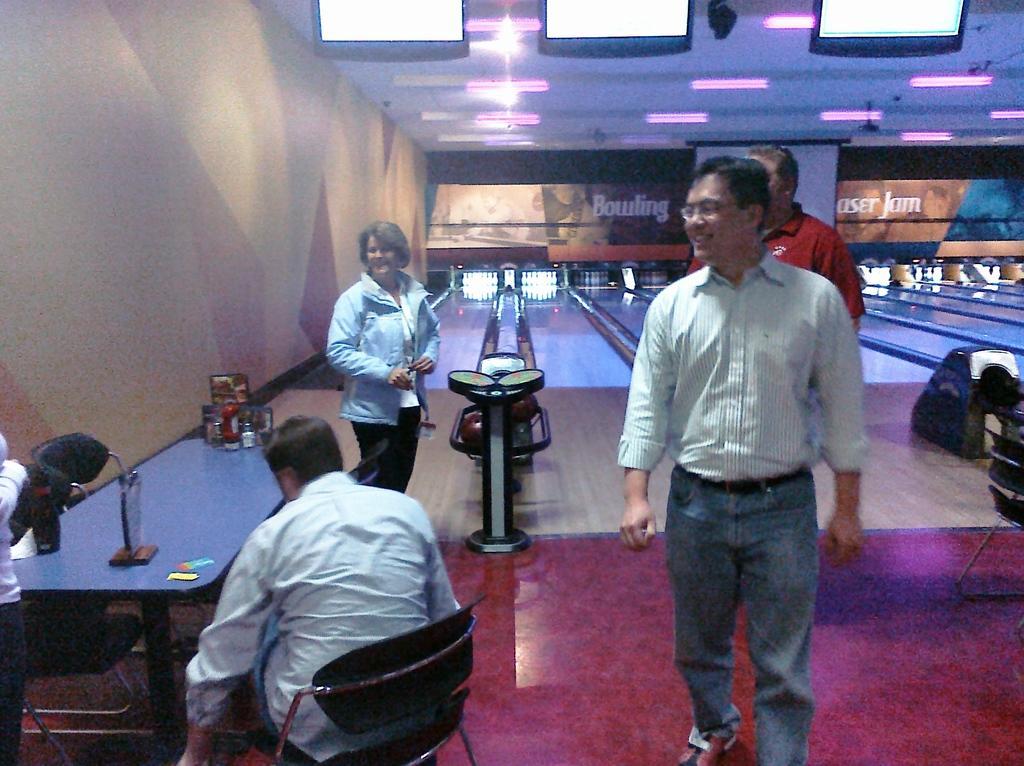How would you summarize this image in a sentence or two? In this picture there are people and we can see board and objects on the table, chairs and floor. In the background of the image we can see bowling game and white banner. At the top of the image we can see lights and screens. 